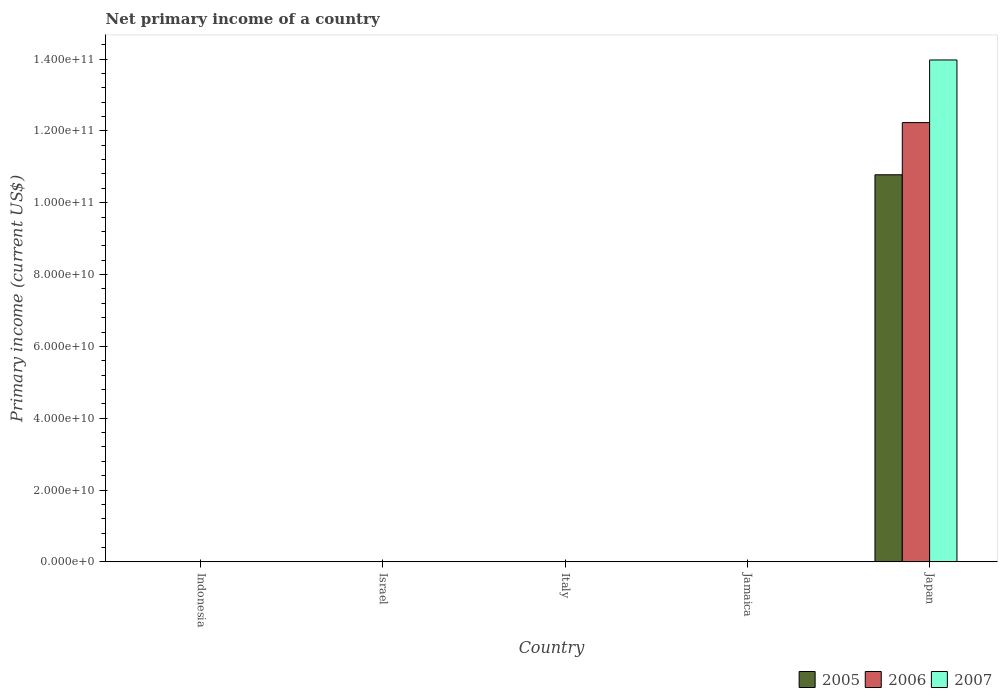How many bars are there on the 4th tick from the left?
Provide a short and direct response. 0. In how many cases, is the number of bars for a given country not equal to the number of legend labels?
Make the answer very short. 4. What is the primary income in 2005 in Japan?
Your answer should be compact. 1.08e+11. Across all countries, what is the maximum primary income in 2007?
Provide a short and direct response. 1.40e+11. Across all countries, what is the minimum primary income in 2007?
Your answer should be compact. 0. What is the total primary income in 2007 in the graph?
Make the answer very short. 1.40e+11. What is the average primary income in 2005 per country?
Ensure brevity in your answer.  2.16e+1. What is the difference between the primary income of/in 2007 and primary income of/in 2005 in Japan?
Offer a very short reply. 3.20e+1. In how many countries, is the primary income in 2007 greater than 104000000000 US$?
Your response must be concise. 1. What is the difference between the highest and the lowest primary income in 2005?
Give a very brief answer. 1.08e+11. In how many countries, is the primary income in 2005 greater than the average primary income in 2005 taken over all countries?
Provide a succinct answer. 1. Is it the case that in every country, the sum of the primary income in 2005 and primary income in 2006 is greater than the primary income in 2007?
Make the answer very short. No. How many bars are there?
Keep it short and to the point. 3. Are all the bars in the graph horizontal?
Your answer should be compact. No. Are the values on the major ticks of Y-axis written in scientific E-notation?
Give a very brief answer. Yes. Does the graph contain grids?
Your response must be concise. No. What is the title of the graph?
Your answer should be compact. Net primary income of a country. Does "1989" appear as one of the legend labels in the graph?
Keep it short and to the point. No. What is the label or title of the Y-axis?
Ensure brevity in your answer.  Primary income (current US$). What is the Primary income (current US$) of 2005 in Indonesia?
Your answer should be compact. 0. What is the Primary income (current US$) of 2007 in Indonesia?
Your answer should be compact. 0. What is the Primary income (current US$) of 2005 in Israel?
Make the answer very short. 0. What is the Primary income (current US$) in 2006 in Israel?
Your answer should be very brief. 0. What is the Primary income (current US$) of 2007 in Israel?
Your answer should be compact. 0. What is the Primary income (current US$) in 2005 in Italy?
Your answer should be very brief. 0. What is the Primary income (current US$) of 2007 in Italy?
Your answer should be very brief. 0. What is the Primary income (current US$) of 2006 in Jamaica?
Keep it short and to the point. 0. What is the Primary income (current US$) in 2007 in Jamaica?
Offer a terse response. 0. What is the Primary income (current US$) of 2005 in Japan?
Keep it short and to the point. 1.08e+11. What is the Primary income (current US$) of 2006 in Japan?
Your answer should be very brief. 1.22e+11. What is the Primary income (current US$) of 2007 in Japan?
Your answer should be very brief. 1.40e+11. Across all countries, what is the maximum Primary income (current US$) in 2005?
Your response must be concise. 1.08e+11. Across all countries, what is the maximum Primary income (current US$) of 2006?
Provide a succinct answer. 1.22e+11. Across all countries, what is the maximum Primary income (current US$) in 2007?
Your answer should be very brief. 1.40e+11. Across all countries, what is the minimum Primary income (current US$) of 2006?
Offer a very short reply. 0. What is the total Primary income (current US$) of 2005 in the graph?
Offer a terse response. 1.08e+11. What is the total Primary income (current US$) of 2006 in the graph?
Your answer should be very brief. 1.22e+11. What is the total Primary income (current US$) of 2007 in the graph?
Provide a short and direct response. 1.40e+11. What is the average Primary income (current US$) in 2005 per country?
Make the answer very short. 2.16e+1. What is the average Primary income (current US$) of 2006 per country?
Give a very brief answer. 2.45e+1. What is the average Primary income (current US$) in 2007 per country?
Provide a succinct answer. 2.79e+1. What is the difference between the Primary income (current US$) in 2005 and Primary income (current US$) in 2006 in Japan?
Your response must be concise. -1.45e+1. What is the difference between the Primary income (current US$) in 2005 and Primary income (current US$) in 2007 in Japan?
Your response must be concise. -3.20e+1. What is the difference between the Primary income (current US$) of 2006 and Primary income (current US$) of 2007 in Japan?
Your answer should be very brief. -1.74e+1. What is the difference between the highest and the lowest Primary income (current US$) in 2005?
Offer a very short reply. 1.08e+11. What is the difference between the highest and the lowest Primary income (current US$) in 2006?
Your answer should be compact. 1.22e+11. What is the difference between the highest and the lowest Primary income (current US$) in 2007?
Provide a short and direct response. 1.40e+11. 